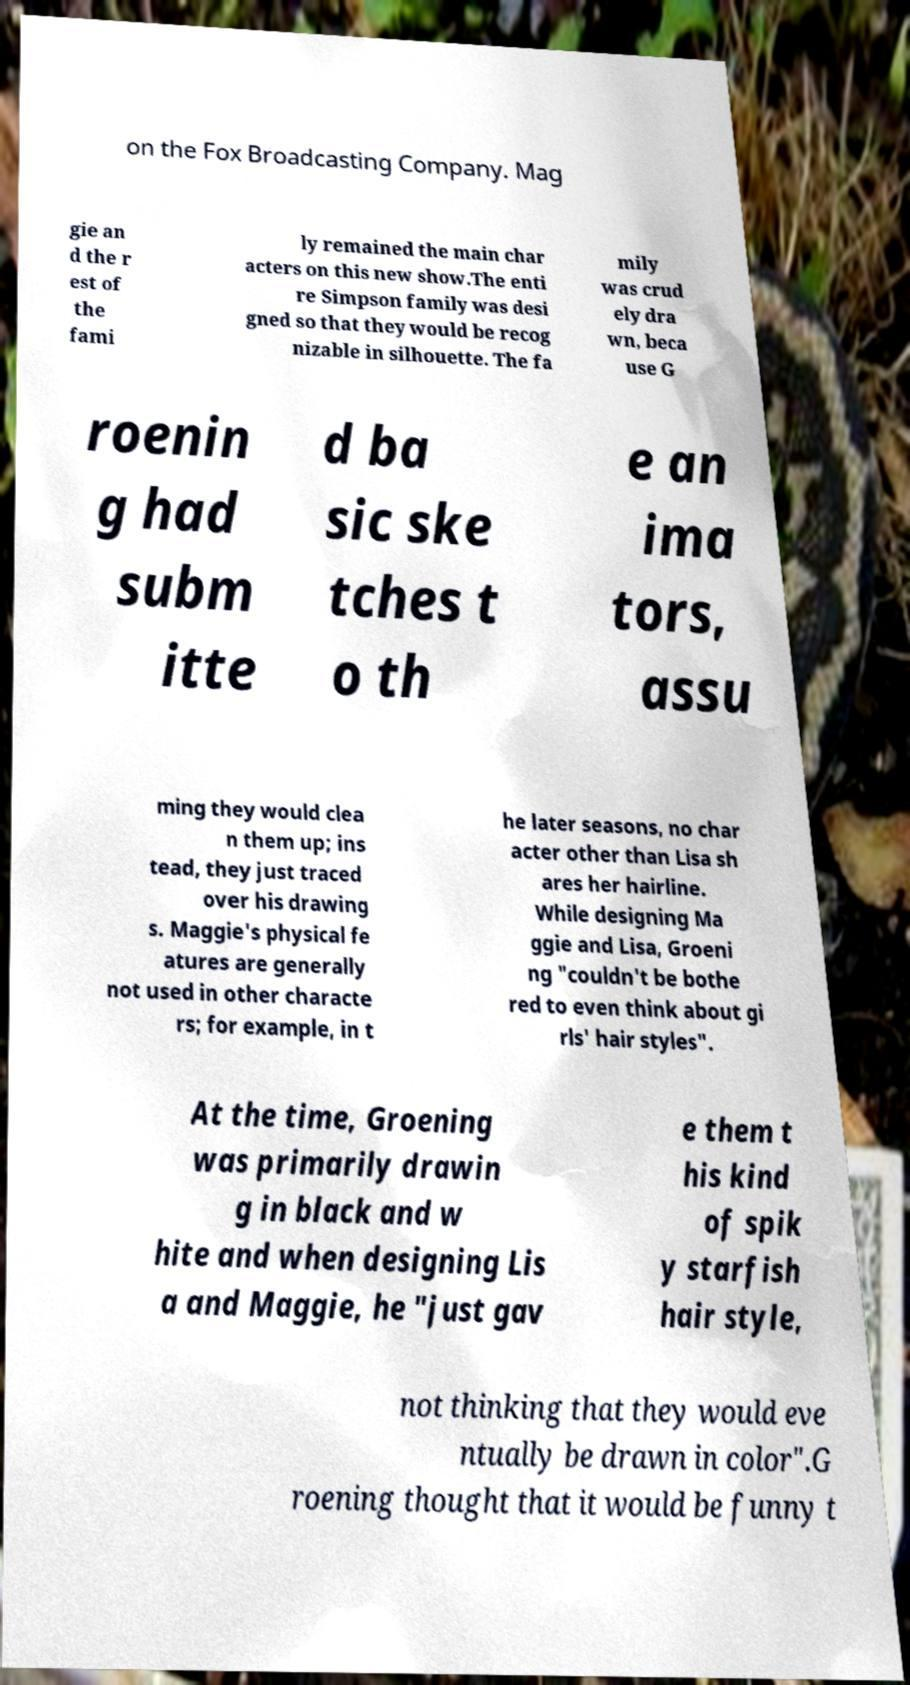Please read and relay the text visible in this image. What does it say? on the Fox Broadcasting Company. Mag gie an d the r est of the fami ly remained the main char acters on this new show.The enti re Simpson family was desi gned so that they would be recog nizable in silhouette. The fa mily was crud ely dra wn, beca use G roenin g had subm itte d ba sic ske tches t o th e an ima tors, assu ming they would clea n them up; ins tead, they just traced over his drawing s. Maggie's physical fe atures are generally not used in other characte rs; for example, in t he later seasons, no char acter other than Lisa sh ares her hairline. While designing Ma ggie and Lisa, Groeni ng "couldn't be bothe red to even think about gi rls' hair styles". At the time, Groening was primarily drawin g in black and w hite and when designing Lis a and Maggie, he "just gav e them t his kind of spik y starfish hair style, not thinking that they would eve ntually be drawn in color".G roening thought that it would be funny t 